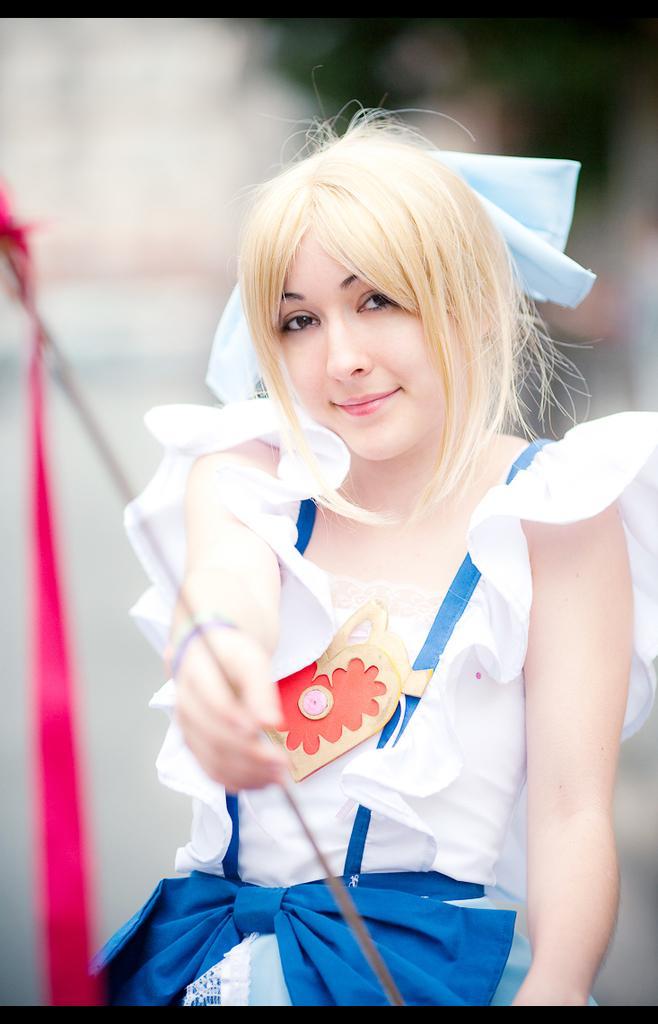Can you describe this image briefly? In this image, we can see a girl, she is holding an object and there is a blur background. 